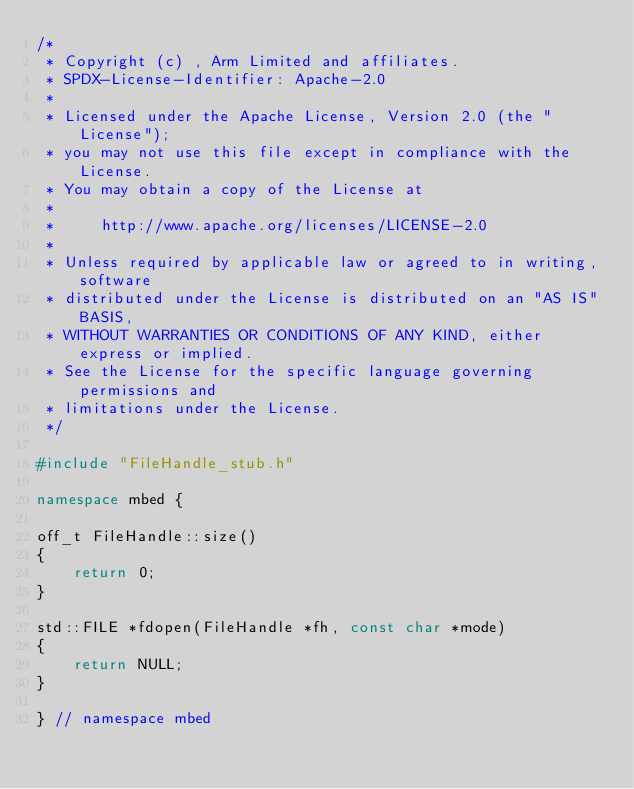<code> <loc_0><loc_0><loc_500><loc_500><_C++_>/*
 * Copyright (c) , Arm Limited and affiliates.
 * SPDX-License-Identifier: Apache-2.0
 *
 * Licensed under the Apache License, Version 2.0 (the "License");
 * you may not use this file except in compliance with the License.
 * You may obtain a copy of the License at
 *
 *     http://www.apache.org/licenses/LICENSE-2.0
 *
 * Unless required by applicable law or agreed to in writing, software
 * distributed under the License is distributed on an "AS IS" BASIS,
 * WITHOUT WARRANTIES OR CONDITIONS OF ANY KIND, either express or implied.
 * See the License for the specific language governing permissions and
 * limitations under the License.
 */

#include "FileHandle_stub.h"

namespace mbed {

off_t FileHandle::size()
{
    return 0;
}

std::FILE *fdopen(FileHandle *fh, const char *mode)
{
    return NULL;
}

} // namespace mbed
</code> 